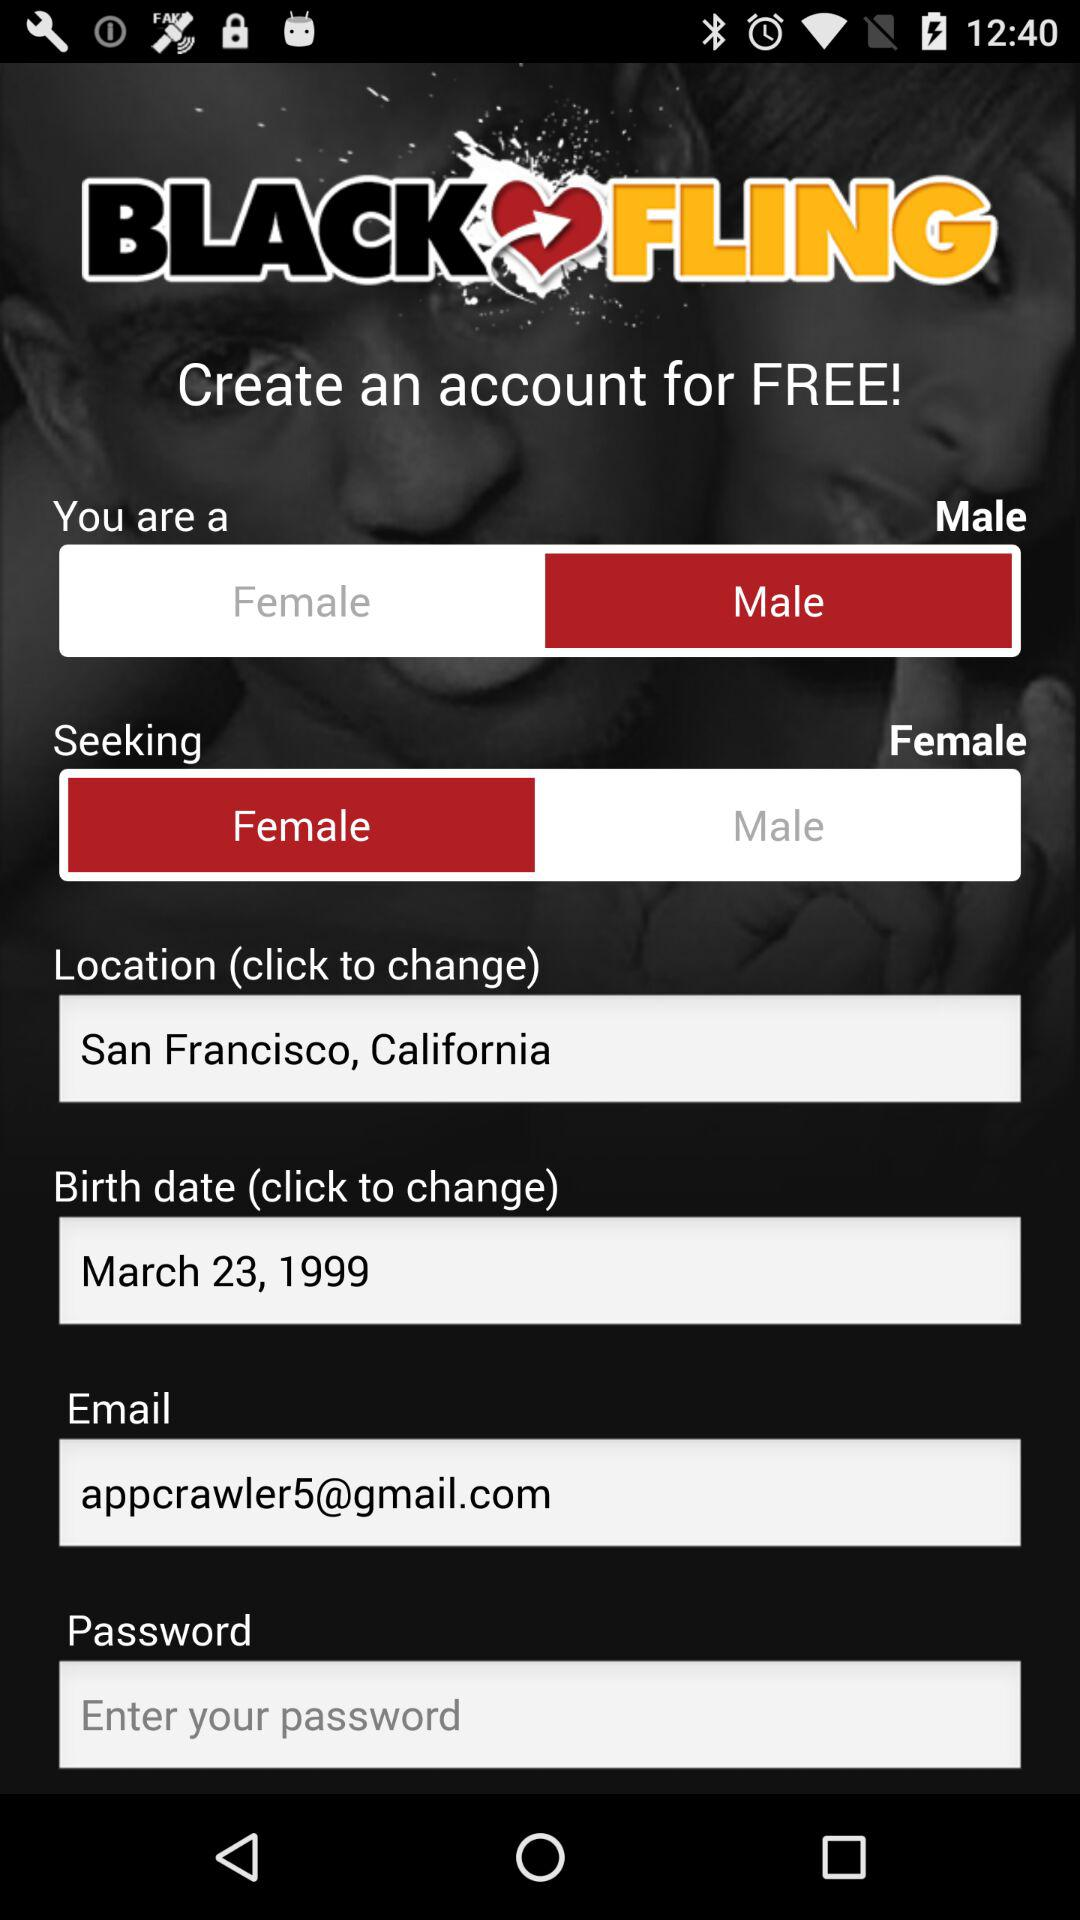What is the location? The location is San Francisco, California. 